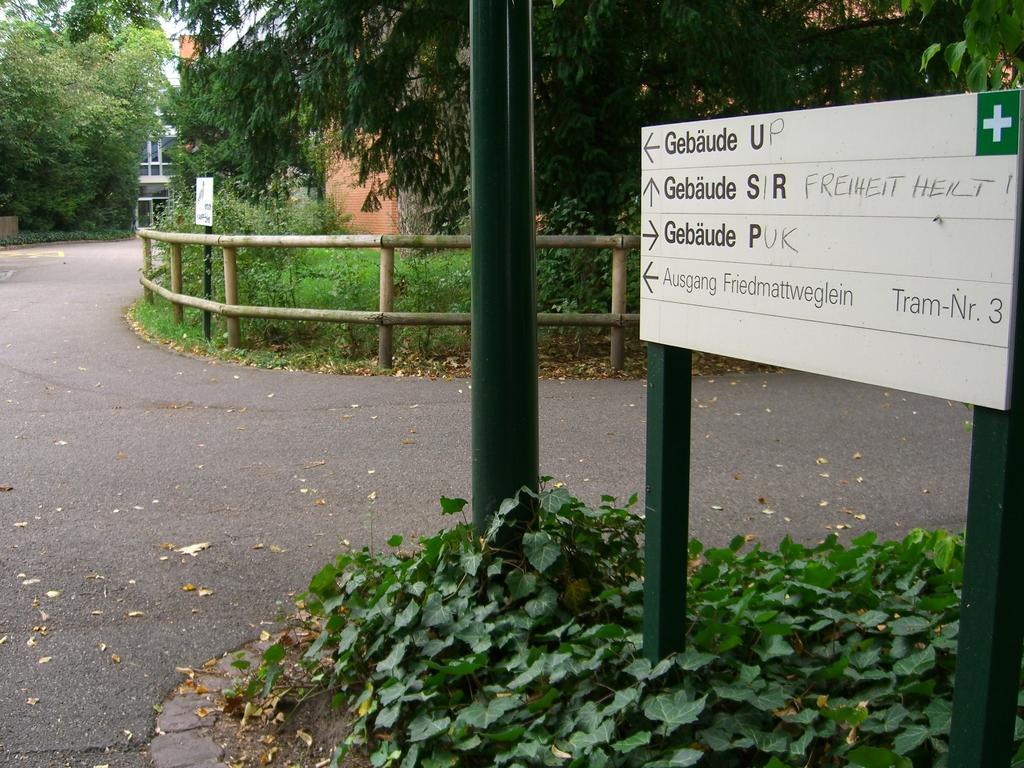Please provide a concise description of this image. In this picture we can observe a road. There is a green color pole. We can observe a white color board fixed to the two green color poles. There are some plants. We can observe a wooden railing here. In the background there are trees. 